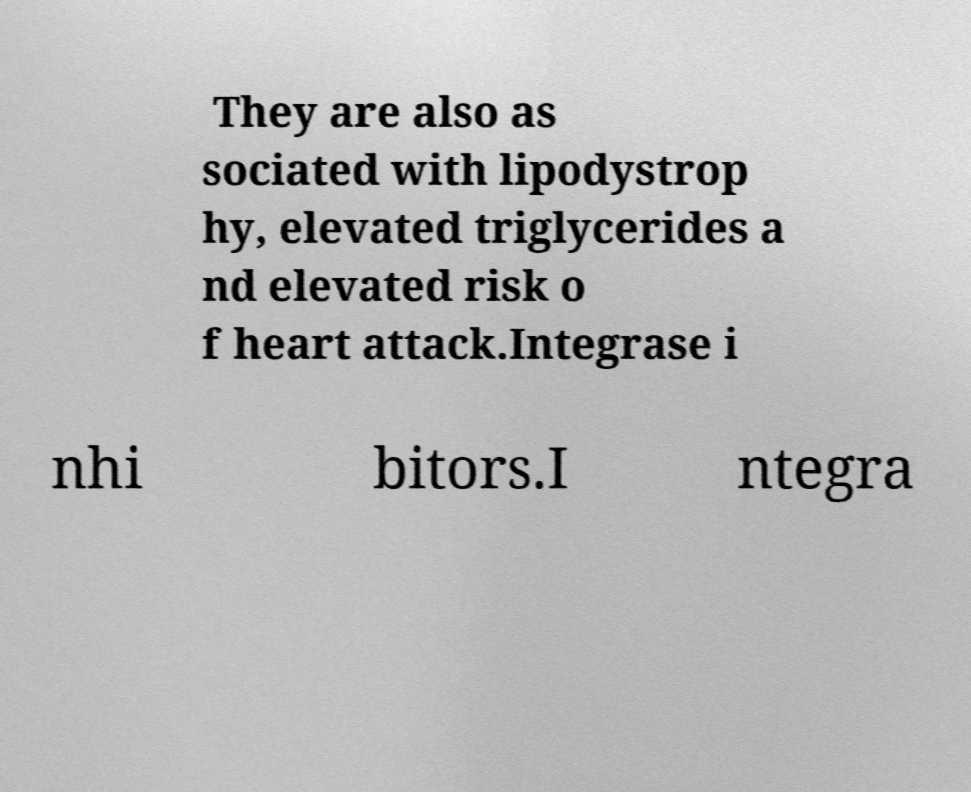Please read and relay the text visible in this image. What does it say? They are also as sociated with lipodystrop hy, elevated triglycerides a nd elevated risk o f heart attack.Integrase i nhi bitors.I ntegra 